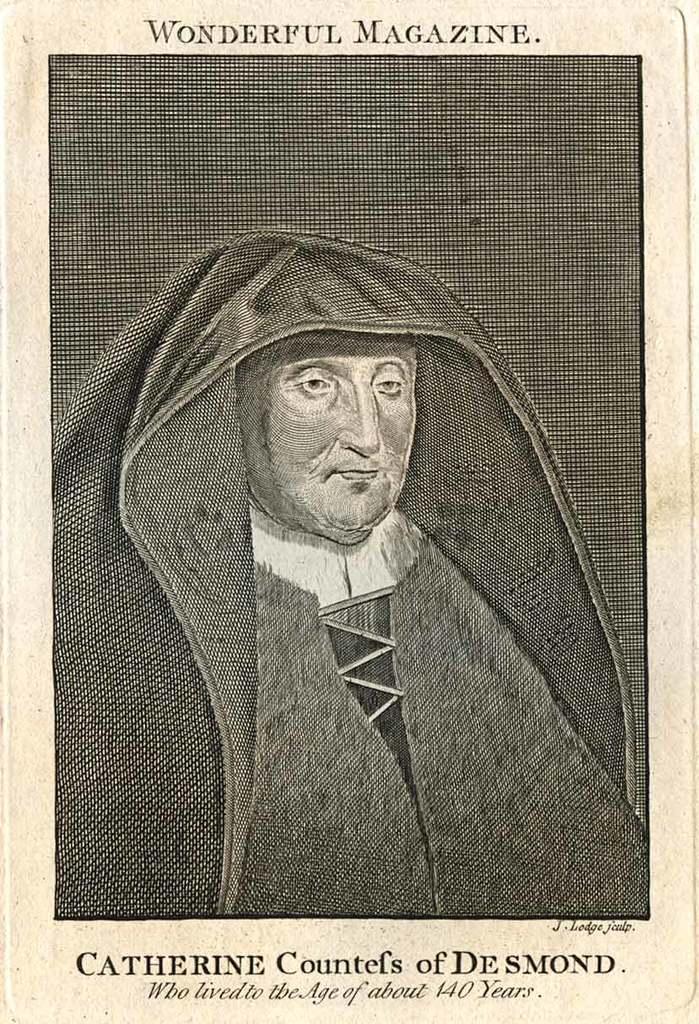Can you describe this image briefly? In this image we can see a poster. On the poster we can see picture of a person and something is written on it. 